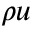<formula> <loc_0><loc_0><loc_500><loc_500>\rho u</formula> 